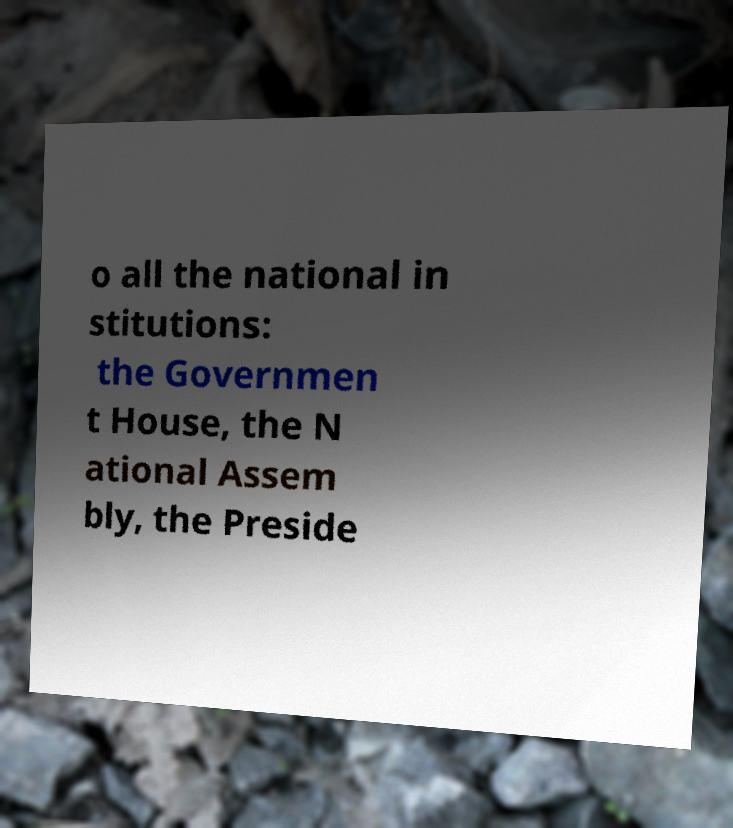Please read and relay the text visible in this image. What does it say? o all the national in stitutions: the Governmen t House, the N ational Assem bly, the Preside 